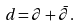Convert formula to latex. <formula><loc_0><loc_0><loc_500><loc_500>d = \partial + \bar { \partial } .</formula> 